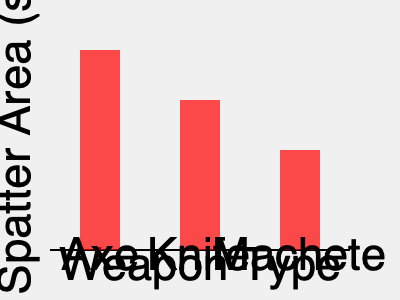In the graph above, which weapon produces the largest blood spatter area, and how does this correlate with its effectiveness in classic slasher films? To answer this question, we need to analyze the graph and apply our knowledge of slasher film conventions:

1. Interpret the graph:
   - The y-axis represents the blood spatter area in square centimeters.
   - The x-axis shows three different weapons: Axe, Knife, and Machete.
   - The height of each bar indicates the blood spatter area for each weapon.

2. Compare the blood spatter areas:
   - Axe: Tallest bar, reaching approximately 200 sq cm.
   - Knife: Second tallest, reaching about 150 sq cm.
   - Machete: Shortest bar, reaching around 100 sq cm.

3. Determine the weapon with the largest blood spatter area:
   The Axe produces the largest blood spatter area.

4. Correlate with effectiveness in classic slasher films:
   - Larger blood spatter often correlates with more visceral and impactful on-screen kills.
   - Axes are iconic weapons in slasher films (e.g., "The Shining," "Sleepaway Camp").
   - The larger spatter area of the axe aligns with its reputation for creating dramatic, gory scenes.
   - This effectiveness is due to the axe's weight, large striking surface, and the force it can generate.

5. Consider cinematic impact:
   - Larger blood spatter creates more visually striking scenes.
   - It emphasizes the brutality of the killer and intensifies the horror experience.
   - The axe's larger spatter area contributes to its status as a favored weapon in the genre.

Therefore, the axe produces the largest blood spatter area, which correlates positively with its effectiveness and popularity in classic slasher films due to its ability to create visually impactful and horrifying murder scenes.
Answer: Axe; larger spatter enhances visual impact and emphasizes brutality in slasher films. 